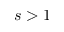<formula> <loc_0><loc_0><loc_500><loc_500>s > 1</formula> 